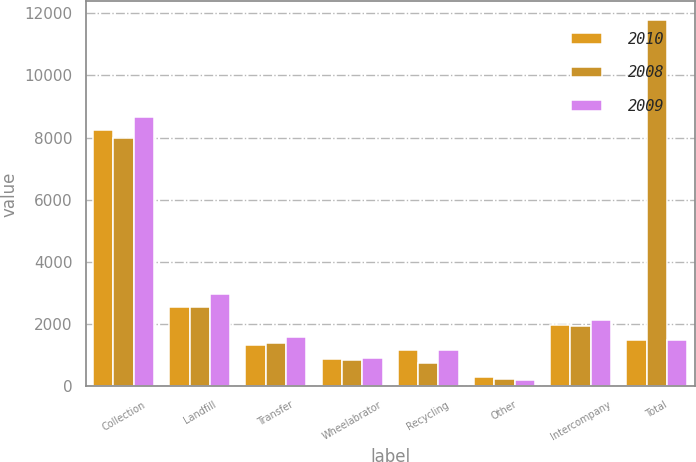<chart> <loc_0><loc_0><loc_500><loc_500><stacked_bar_chart><ecel><fcel>Collection<fcel>Landfill<fcel>Transfer<fcel>Wheelabrator<fcel>Recycling<fcel>Other<fcel>Intercompany<fcel>Total<nl><fcel>2010<fcel>8247<fcel>2540<fcel>1318<fcel>889<fcel>1169<fcel>314<fcel>1962<fcel>1486<nl><fcel>2008<fcel>7980<fcel>2547<fcel>1383<fcel>841<fcel>741<fcel>245<fcel>1946<fcel>11791<nl><fcel>2009<fcel>8679<fcel>2955<fcel>1589<fcel>912<fcel>1180<fcel>207<fcel>2134<fcel>1486<nl></chart> 